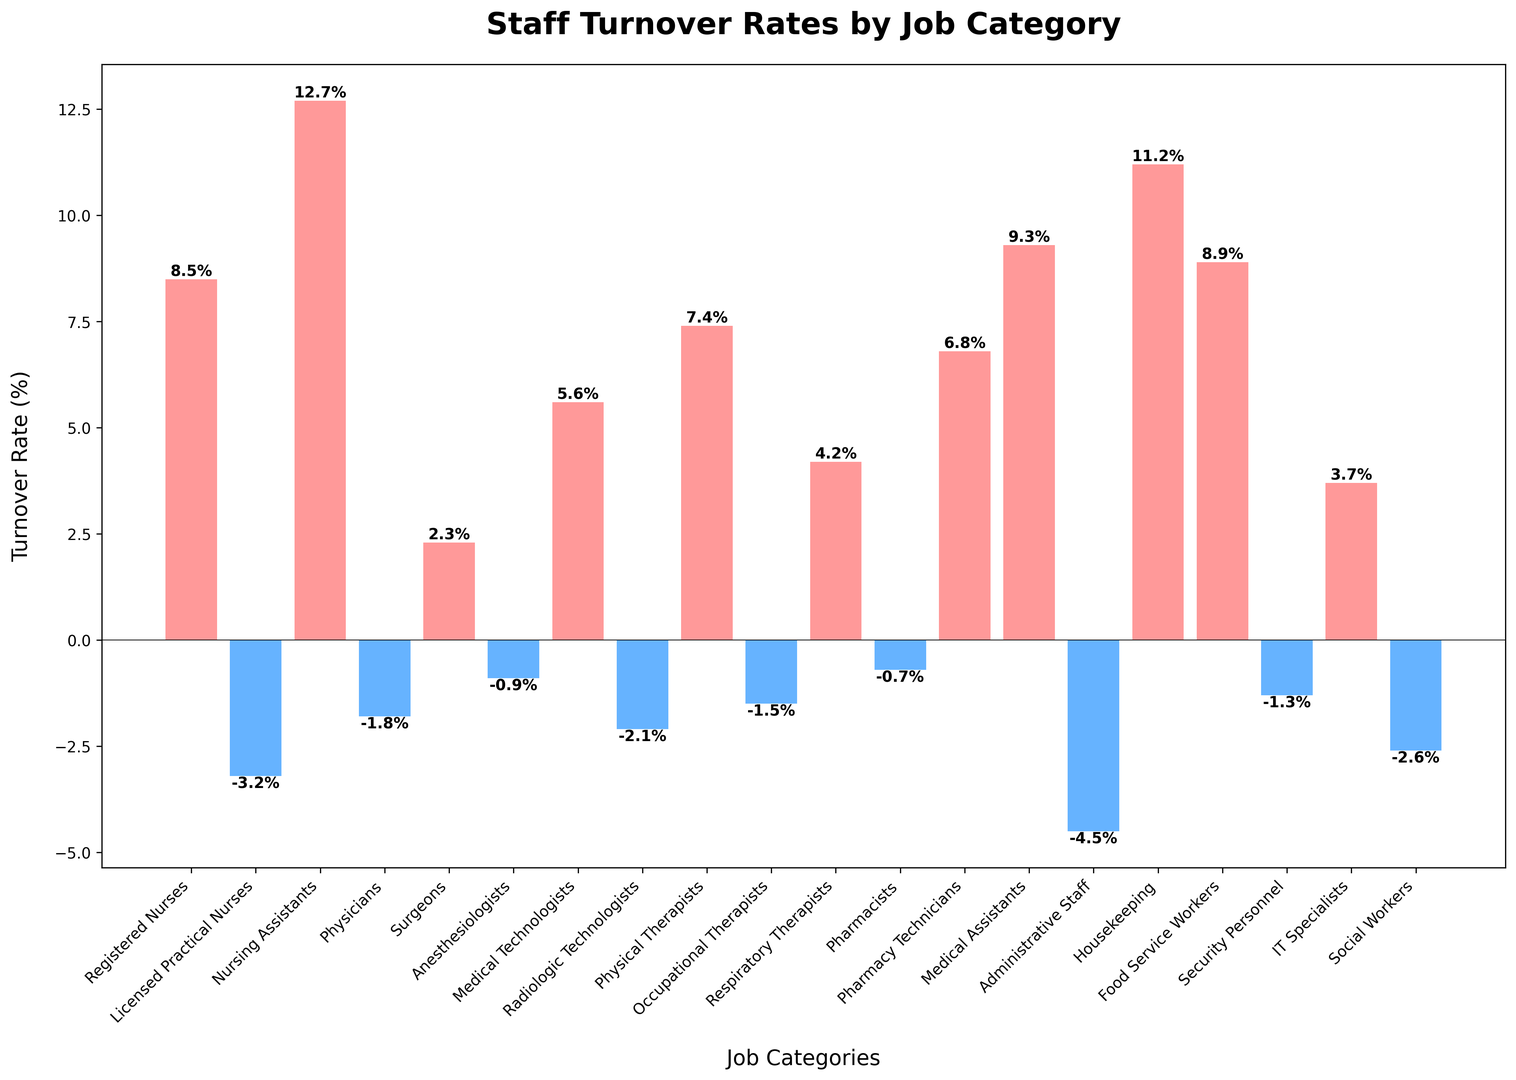How much greater is the turnover rate of Nursing Assistants compared to Registered Nurses? The turnover rate for Nursing Assistants is 12.7%, and for Registered Nurses, it is 8.5%. The difference is 12.7% - 8.5%.
Answer: 4.2% What is the average turnover rate of Physical Therapists and Food Service Workers? Adding the turnover rates of Physical Therapists (7.4%) and Food Service Workers (8.9%), and then dividing by 2. (7.4 + 8.9) / 2.
Answer: 8.15% Is the turnover rate higher for Respiratory Therapists or IT Specialists? Comparing the heights of the bars for Respiratory Therapists (4.2%) and IT Specialists (3.7%).
Answer: Respiratory Therapists Which job categories have negative turnover rates? Looking for the bars that are below the horizontal axis: Licensed Practical Nurses, Physicians, Anesthesiologists, Radiologic Technologists, Occupational Therapists, Pharmacists, Administrative Staff, Security Personnel, Social Workers.
Answer: 9 job categories Combine the turnover rates of Medical Assistants and Food Service Workers. Is it more than 15%? Adding the turnover rates of Medical Assistants (9.3%) and Food Service Workers (8.9%). 9.3% + 8.9% = 18.2%, which is more than 15%.
Answer: Yes, 18.2% Which category, Administrative Staff or Social Workers, has a more negative turnover rate? Comparing the positions of the bars representing Administrative Staff (-4.5%) and Social Workers (-2.6%).
Answer: Administrative Staff Are there more job categories with positive turnover rates or negative turnover rates? Count the bars that are above the horizontal axis for positive turnover rates (9) and below the axis for negative turnover rates (11).
Answer: Negative turnover rates What is the median turnover rate among all job categories? Sorting all turnover rates: -4.5, -3.2, -2.6, -2.1, -1.8, -1.5, -1.3, -0.9, -0.7, 2.3, 3.7, 4.2, 5.6, 6.8, 7.4, 8.5, 8.9, 9.3, 11.2, 12.7. The median is the average of the 10th and 11th values: (2.3 + 3.7) / 2.
Answer: 3.0% 